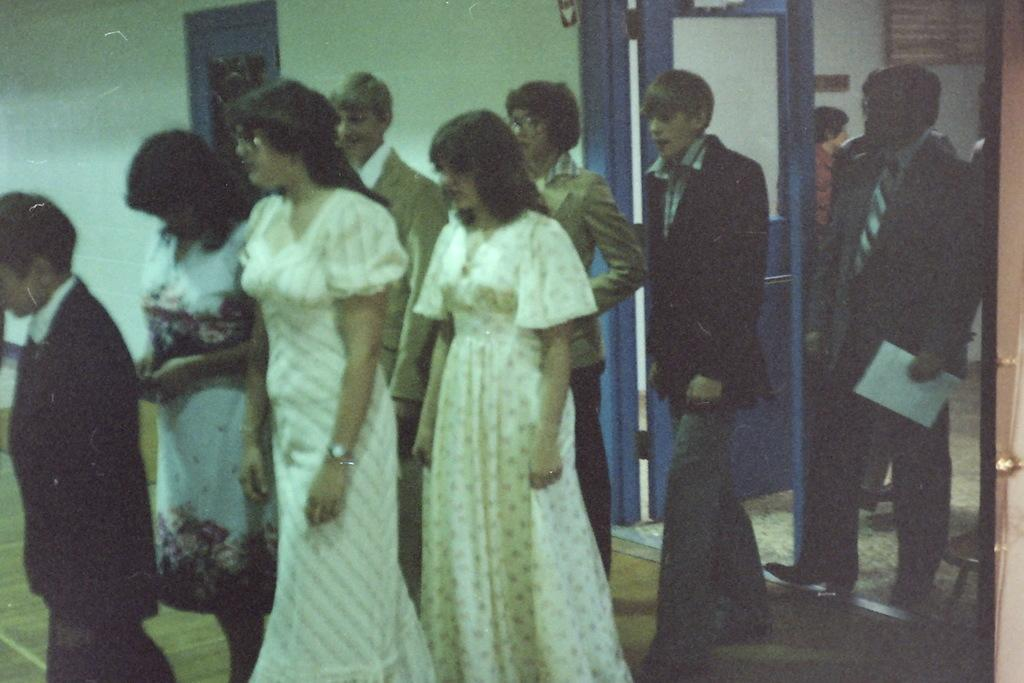How many people are in the image? There is a group of people in the image. Can you describe the clothing of one person in the group? One person in the group is wearing a white dress. What can be seen in the background of the image? There are doors visible in the background of the image, and the wall is white. How many clams are visible on the white wall in the image? There are no clams visible on the white wall in the image. What type of houses can be seen in the background of the image? There is no information about houses in the background of the image; only doors and a white wall are mentioned. 